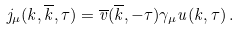Convert formula to latex. <formula><loc_0><loc_0><loc_500><loc_500>j _ { \mu } ( k , \overline { k } , \tau ) = \overline { v } ( \overline { k } , - \tau ) \gamma _ { \mu } u ( k , \tau ) \, .</formula> 